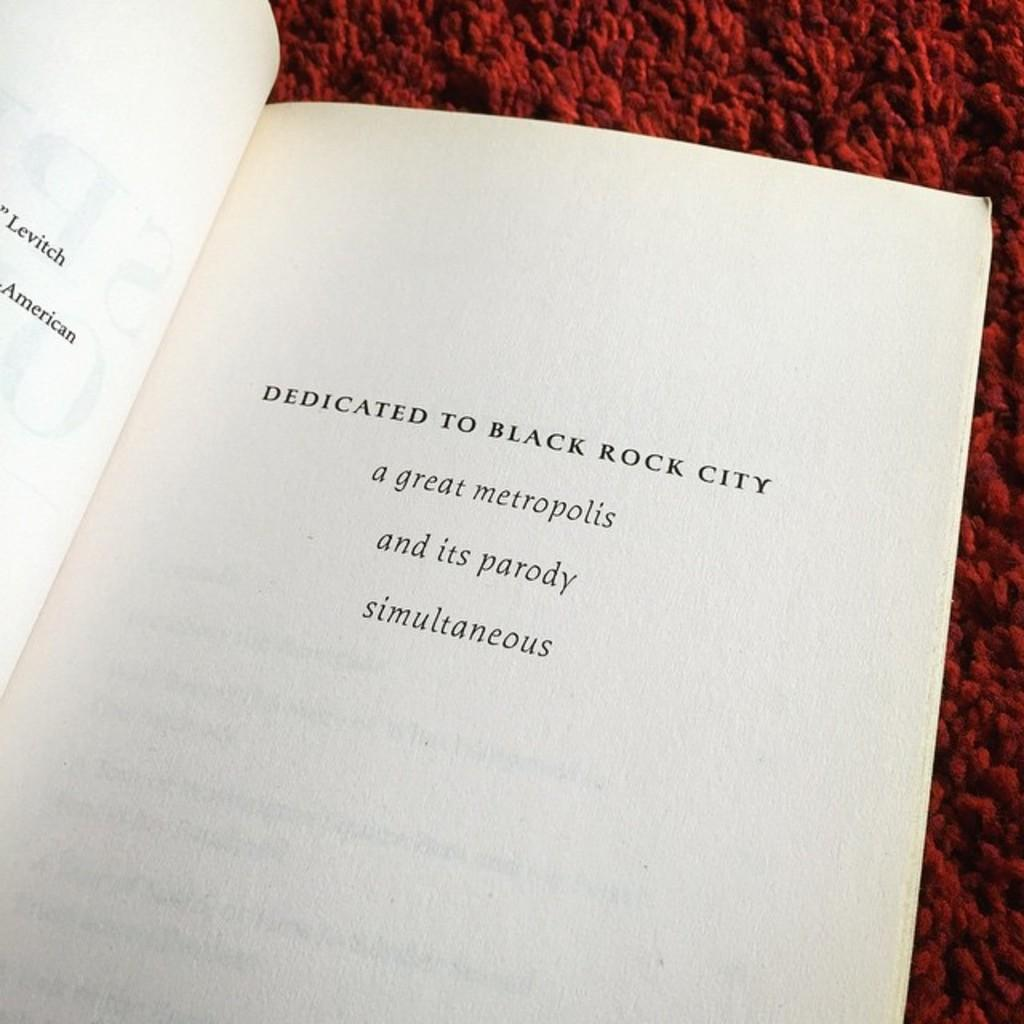<image>
Relay a brief, clear account of the picture shown. An open book which says that it Dedicated to Black Rock City. 